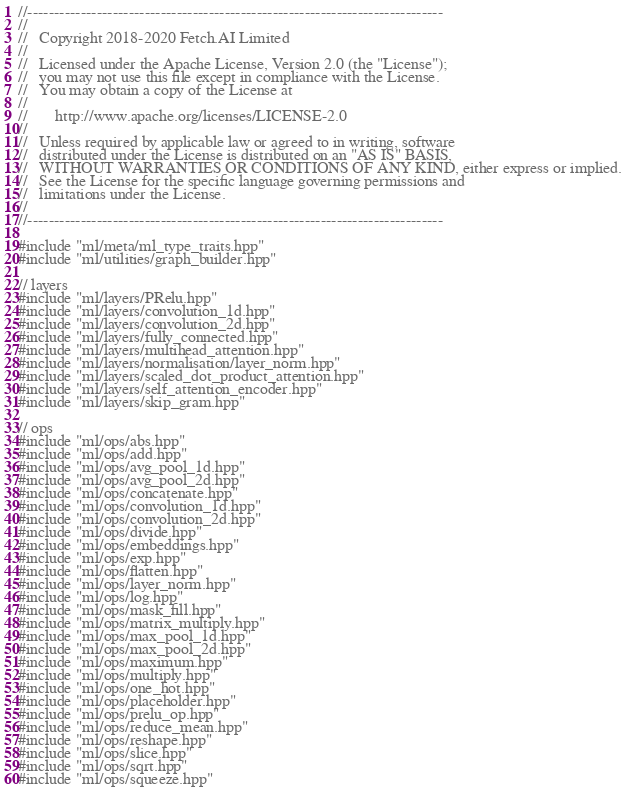Convert code to text. <code><loc_0><loc_0><loc_500><loc_500><_C++_>//------------------------------------------------------------------------------
//
//   Copyright 2018-2020 Fetch.AI Limited
//
//   Licensed under the Apache License, Version 2.0 (the "License");
//   you may not use this file except in compliance with the License.
//   You may obtain a copy of the License at
//
//       http://www.apache.org/licenses/LICENSE-2.0
//
//   Unless required by applicable law or agreed to in writing, software
//   distributed under the License is distributed on an "AS IS" BASIS,
//   WITHOUT WARRANTIES OR CONDITIONS OF ANY KIND, either express or implied.
//   See the License for the specific language governing permissions and
//   limitations under the License.
//
//------------------------------------------------------------------------------

#include "ml/meta/ml_type_traits.hpp"
#include "ml/utilities/graph_builder.hpp"

// layers
#include "ml/layers/PRelu.hpp"
#include "ml/layers/convolution_1d.hpp"
#include "ml/layers/convolution_2d.hpp"
#include "ml/layers/fully_connected.hpp"
#include "ml/layers/multihead_attention.hpp"
#include "ml/layers/normalisation/layer_norm.hpp"
#include "ml/layers/scaled_dot_product_attention.hpp"
#include "ml/layers/self_attention_encoder.hpp"
#include "ml/layers/skip_gram.hpp"

// ops
#include "ml/ops/abs.hpp"
#include "ml/ops/add.hpp"
#include "ml/ops/avg_pool_1d.hpp"
#include "ml/ops/avg_pool_2d.hpp"
#include "ml/ops/concatenate.hpp"
#include "ml/ops/convolution_1d.hpp"
#include "ml/ops/convolution_2d.hpp"
#include "ml/ops/divide.hpp"
#include "ml/ops/embeddings.hpp"
#include "ml/ops/exp.hpp"
#include "ml/ops/flatten.hpp"
#include "ml/ops/layer_norm.hpp"
#include "ml/ops/log.hpp"
#include "ml/ops/mask_fill.hpp"
#include "ml/ops/matrix_multiply.hpp"
#include "ml/ops/max_pool_1d.hpp"
#include "ml/ops/max_pool_2d.hpp"
#include "ml/ops/maximum.hpp"
#include "ml/ops/multiply.hpp"
#include "ml/ops/one_hot.hpp"
#include "ml/ops/placeholder.hpp"
#include "ml/ops/prelu_op.hpp"
#include "ml/ops/reduce_mean.hpp"
#include "ml/ops/reshape.hpp"
#include "ml/ops/slice.hpp"
#include "ml/ops/sqrt.hpp"
#include "ml/ops/squeeze.hpp"</code> 